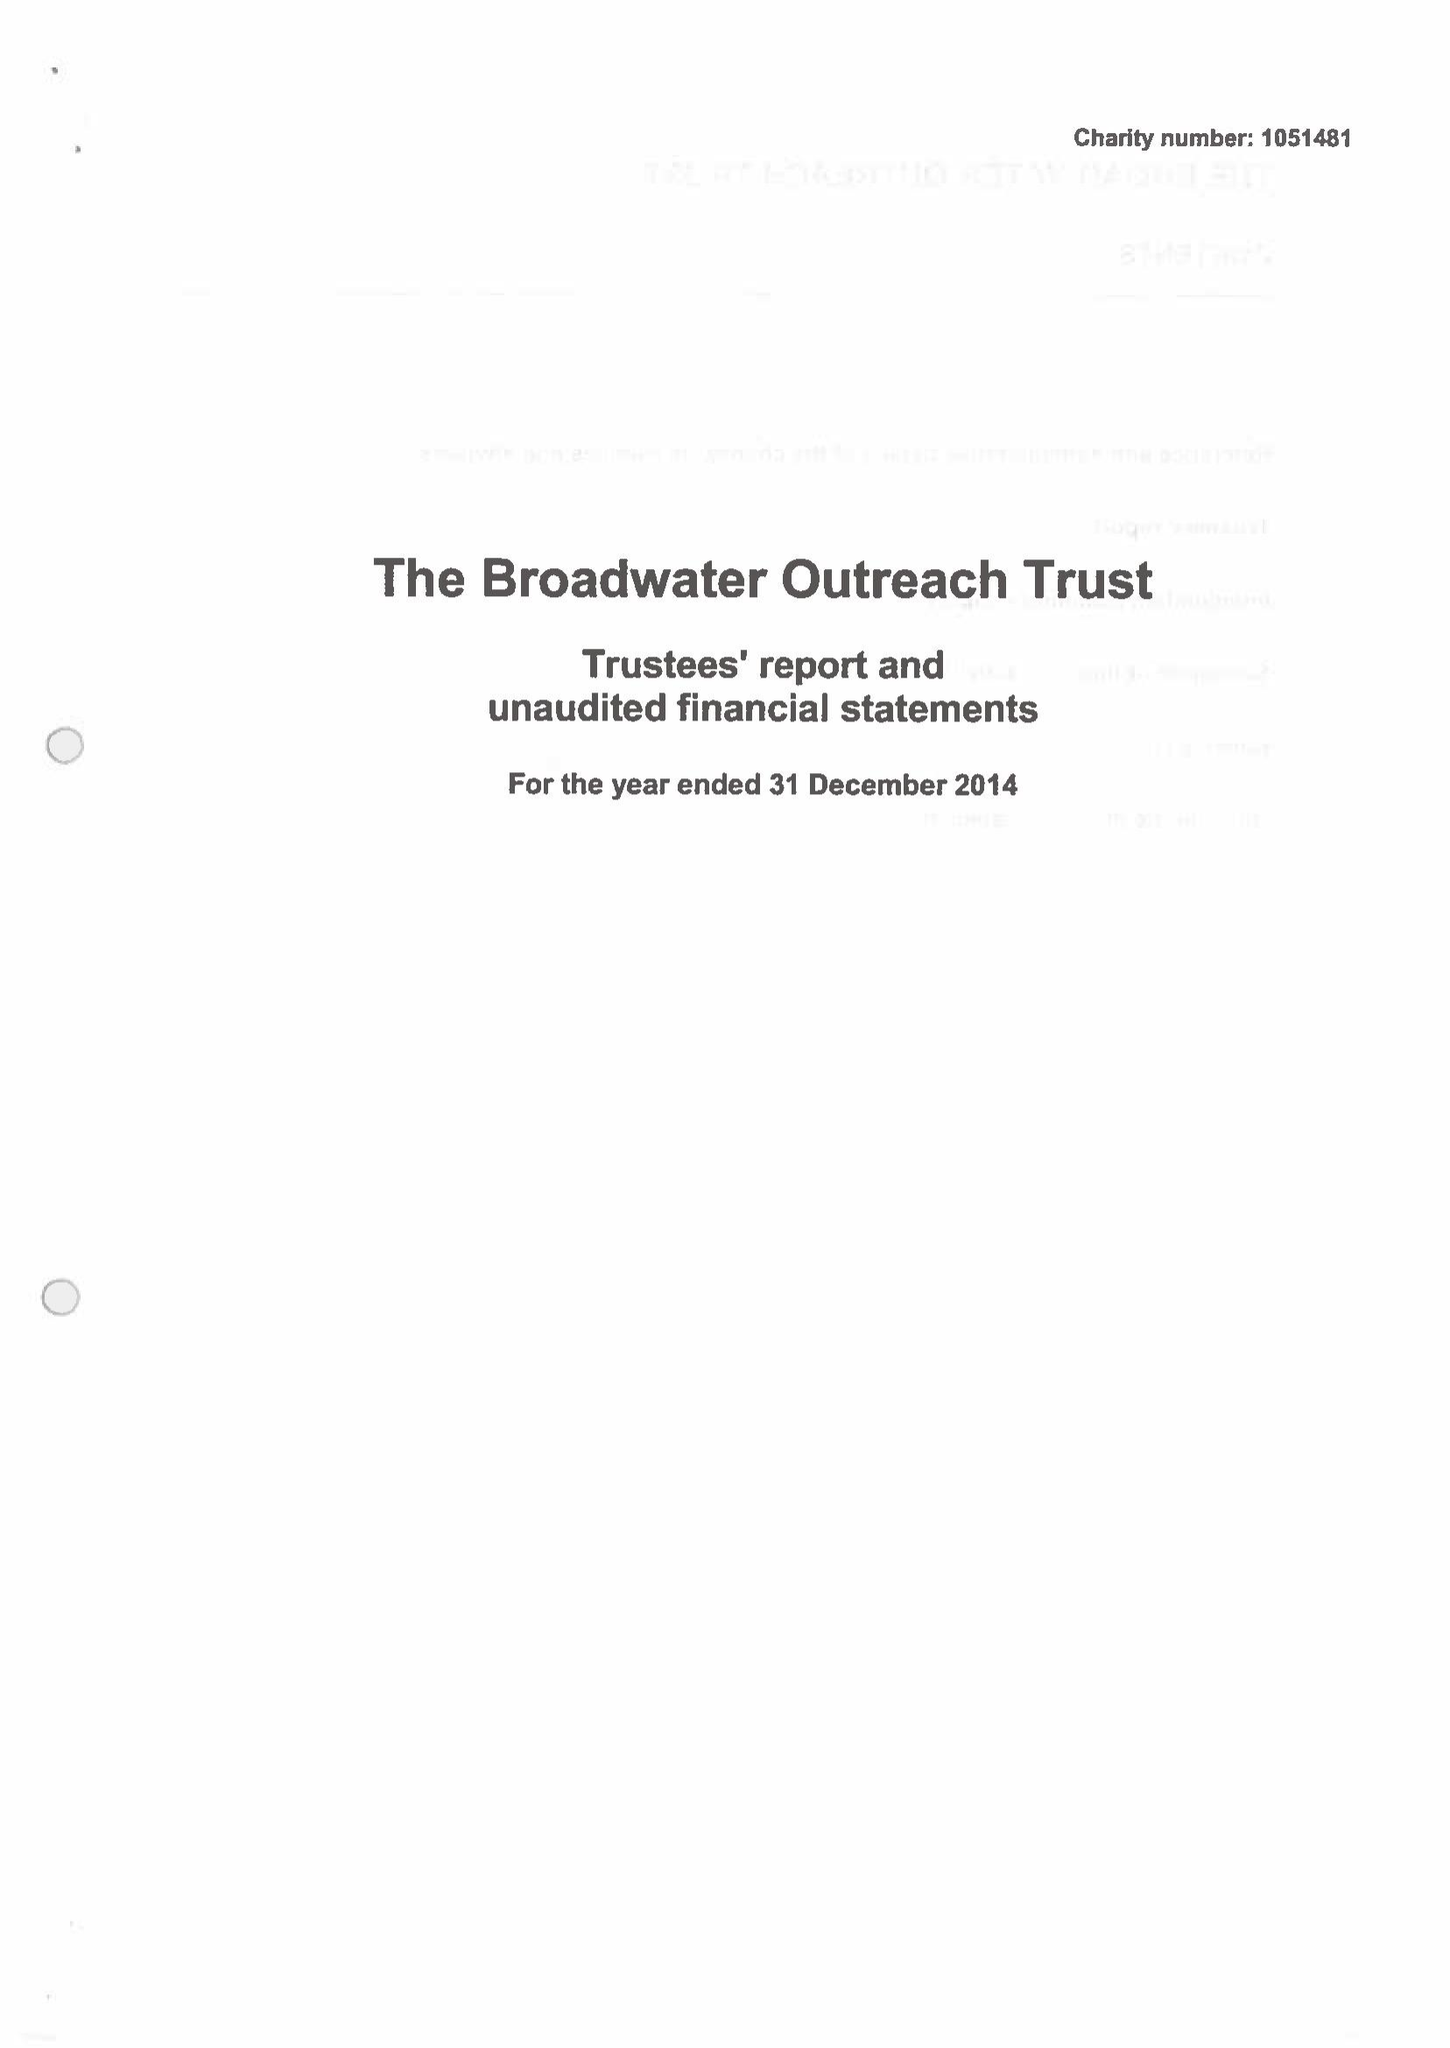What is the value for the address__postcode?
Answer the question using a single word or phrase. BN14 8HT 